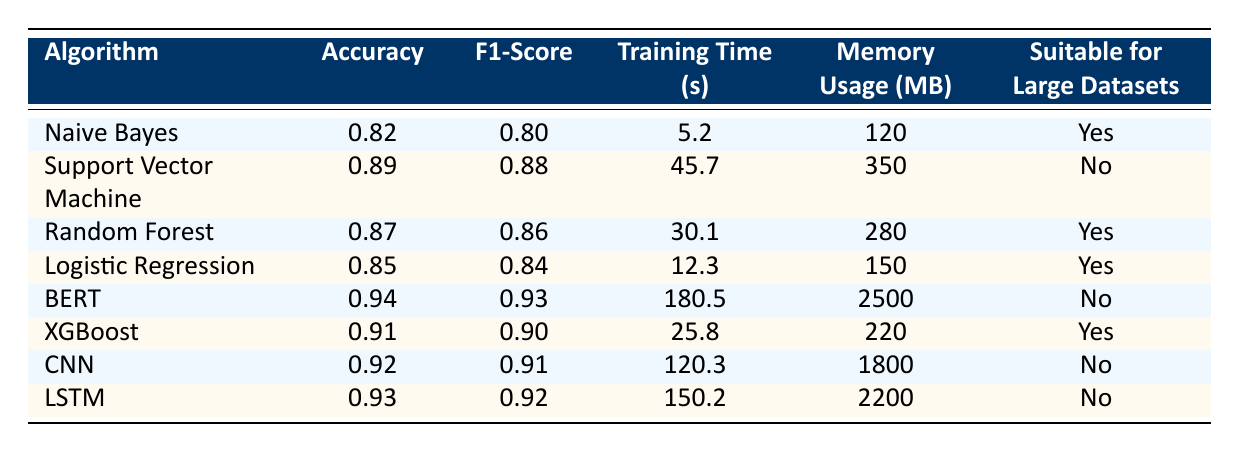What is the accuracy of the Random Forest algorithm? The table shows that the accuracy of the Random Forest algorithm is listed as 0.87.
Answer: 0.87 Which algorithm has the highest F1-Score? From the table, the highest F1-Score belongs to BERT, with a score of 0.93.
Answer: 0.93 How much training time does Naive Bayes require compared to Logistic Regression? The training time for Naive Bayes is 5.2 seconds, while Logistic Regression takes 12.3 seconds. The difference in training time is 12.3 - 5.2 = 7.1 seconds.
Answer: 7.1 seconds Is Support Vector Machine suitable for large datasets? According to the table, Support Vector Machine is marked as "No" for suitability for large datasets.
Answer: No Which algorithms use more than 200 MB of memory? By checking the memory usage in the table, BERT (2500 MB), CNN (1800 MB), and LSTM (2200 MB) use more than 200 MB of memory.
Answer: BERT, CNN, LSTM What is the average accuracy of the algorithms suitable for large datasets? The algorithms suitable for large datasets listed in the table are Naive Bayes (0.82), Random Forest (0.87), Logistic Regression (0.85), and XGBoost (0.91). To find the average accuracy: (0.82 + 0.87 + 0.85 + 0.91) / 4 = 0.86.
Answer: 0.86 Which algorithm has the longest training time and what is that time? BERT has the longest training time, which is 180.5 seconds as shown in the table.
Answer: 180.5 seconds How does the F1-Score of XGBoost compare with that of Naive Bayes? The F1-Score of XGBoost is 0.90, whereas Naive Bayes has an F1-Score of 0.80. The difference is 0.90 - 0.80 = 0.10, indicating XGBoost performs better in this metric.
Answer: 0.10 Are more algorithms marked as 'Yes' or 'No' for suitability for large datasets? Counting the "Yes" responses, we have Naive Bayes, Random Forest, Logistic Regression, and XGBoost (4 total), while the "No" responses are for Support Vector Machine, BERT, CNN, and LSTM (4 total). There is a tie between the two categories.
Answer: Tie 